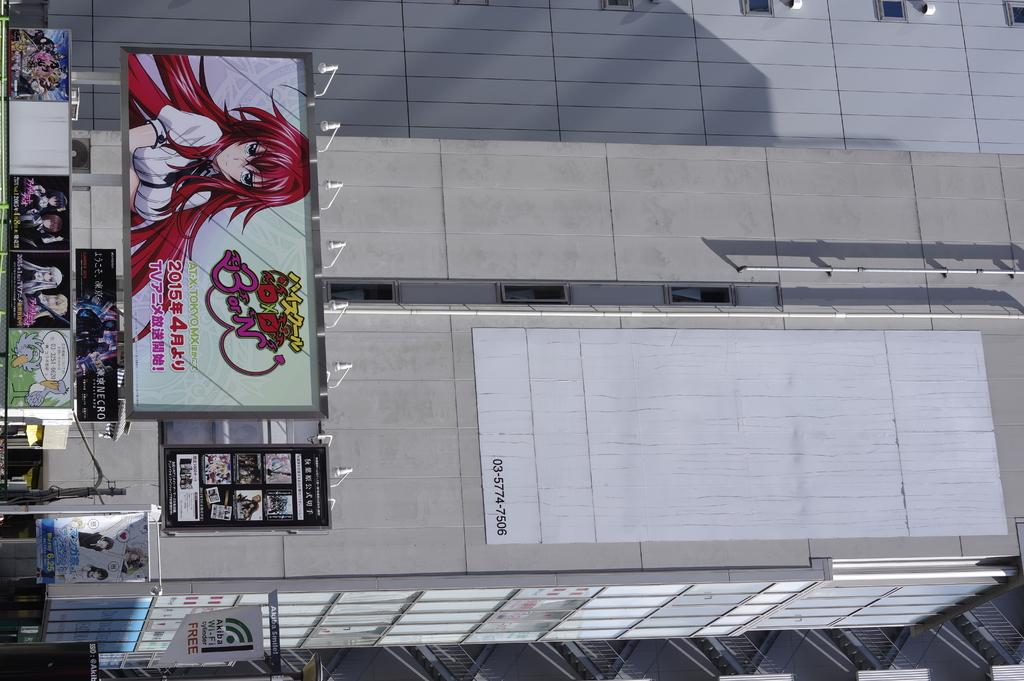What type of structures can be seen in the image? There are posts, poles, and a building in the image. What else can be found in the image besides the structures? There are railings and some unspecified objects in the image. Can you hear the cabbage crying in the image? There is no cabbage present in the image, and therefore it cannot be crying. 